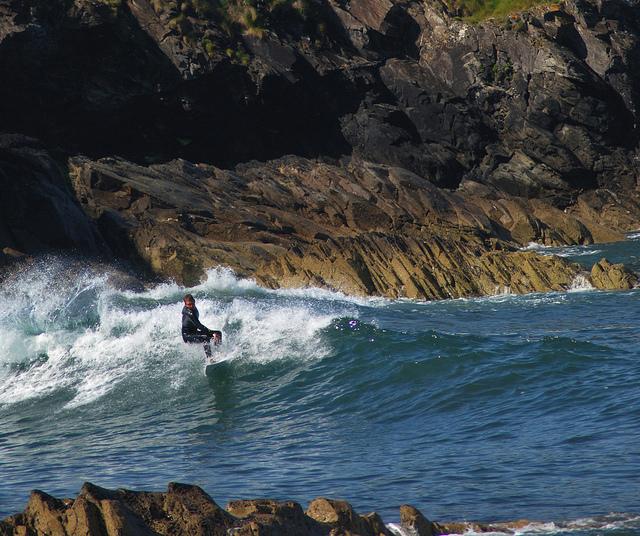Is this a swimming pool?
Quick response, please. No. What is the surfer wearing?
Short answer required. Wetsuit. Is the water calm?
Answer briefly. No. 